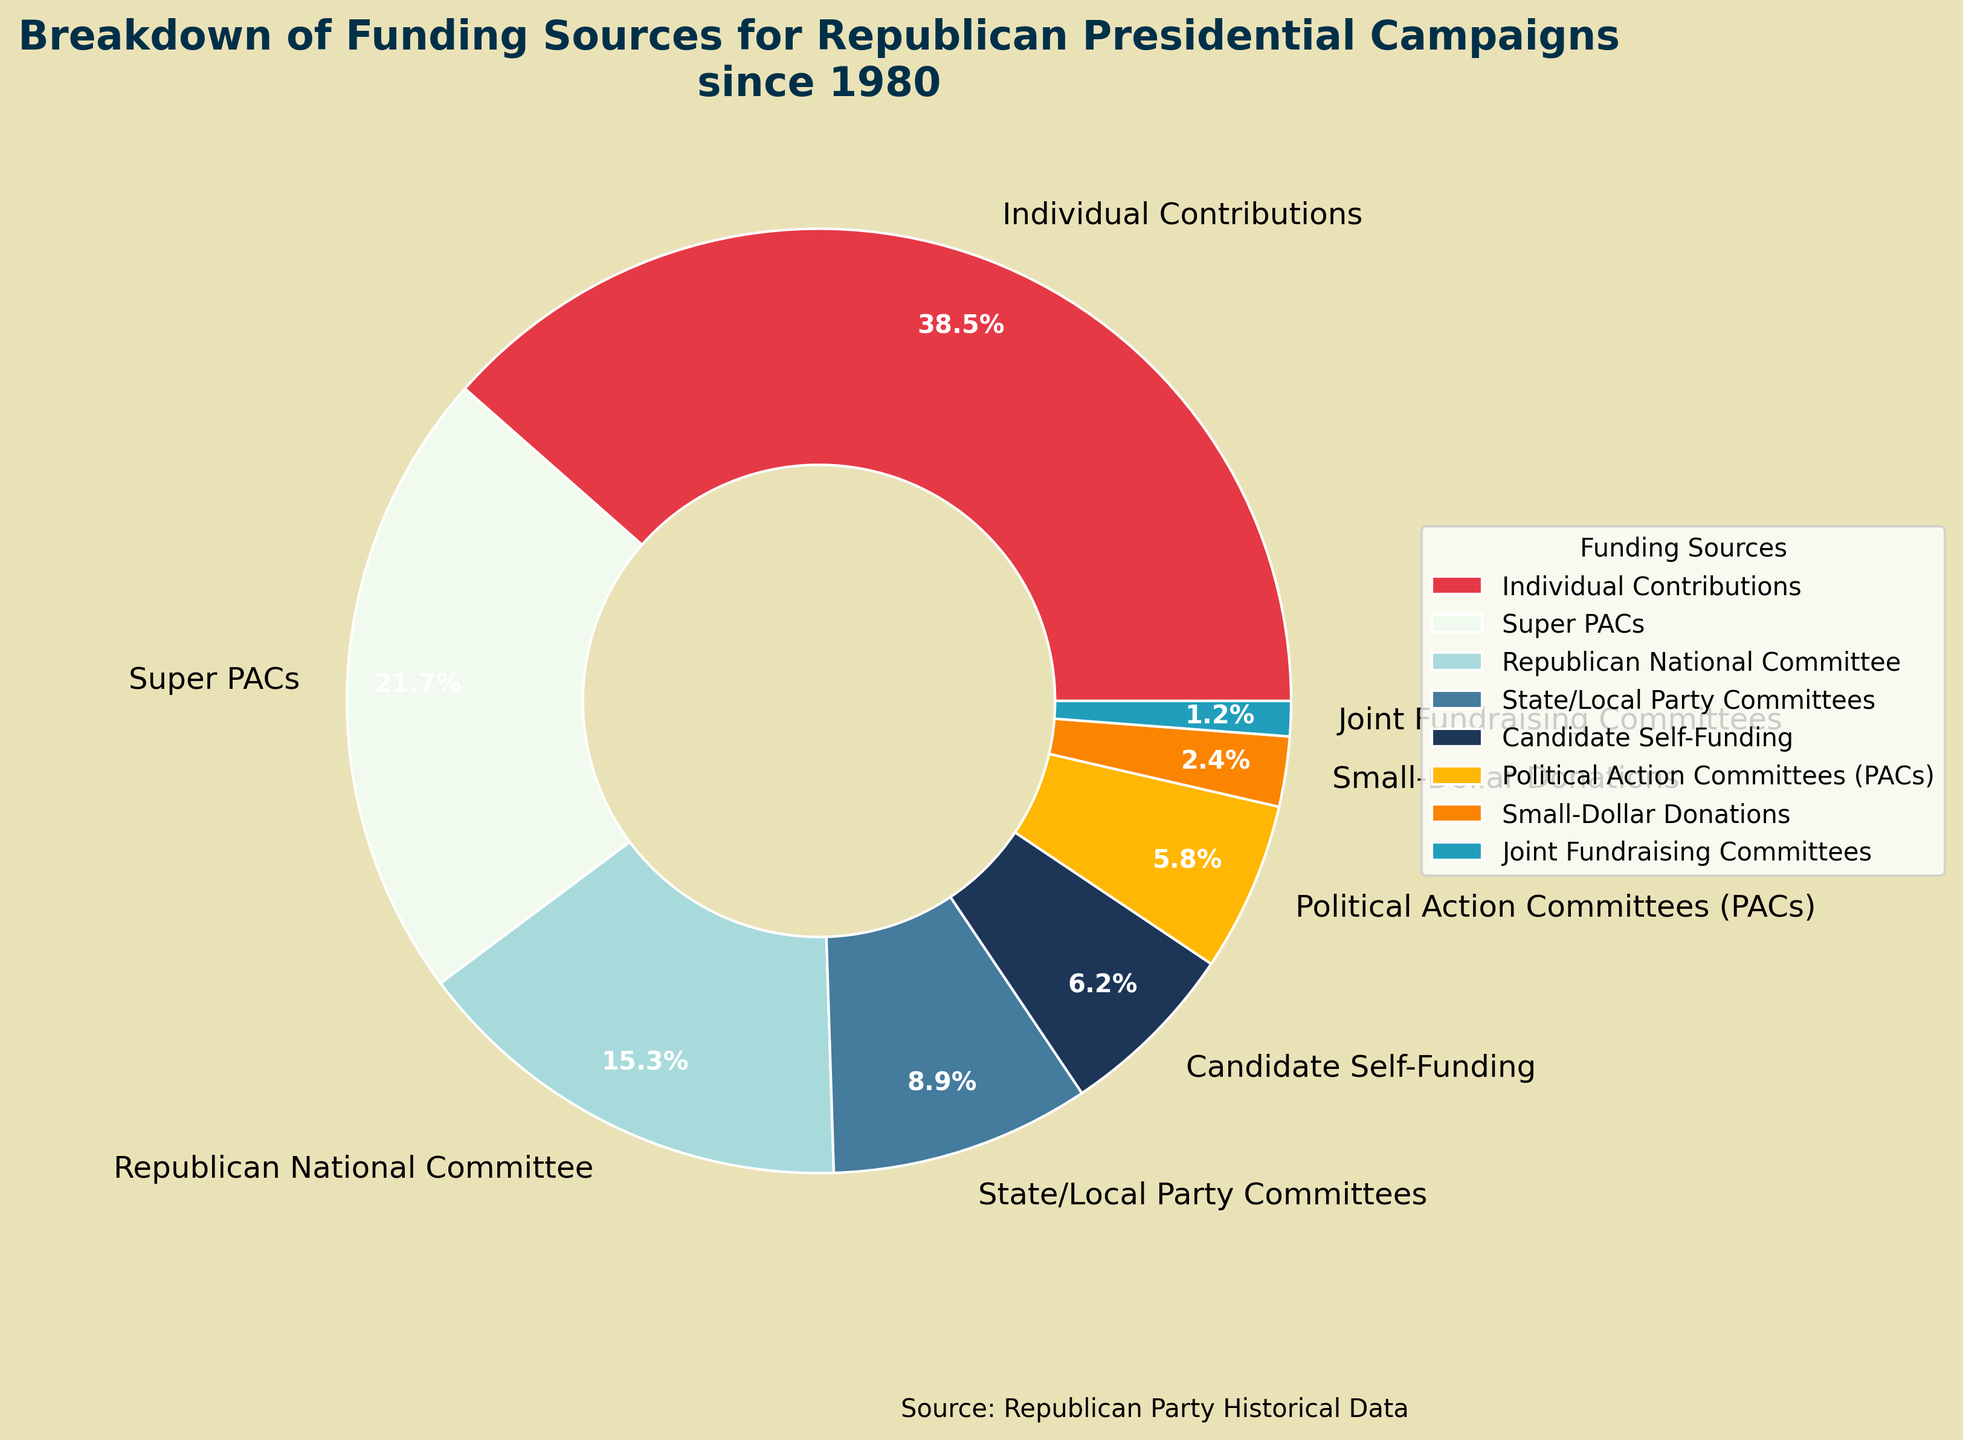What funding source contributes the most to Republican presidential campaigns? From the pie chart, the largest slice corresponds to "Individual Contributions" with 38.5%, indicating it is the biggest source of funding.
Answer: Individual Contributions How much more percentage do Super PACs contribute compared to PACs? First, identify the percentage for each category from the pie chart: Super PACs contribute 21.7%, and PACs contribute 5.8%. Calculate the difference: 21.7% - 5.8% = 15.9%.
Answer: 15.9% Which funding source contributes the least and by how much? The smallest slice in the pie chart corresponds to "Joint Fundraising Committees" with 1.2%. To confirm it's the least, scan all other percentages to compare.
Answer: Joint Fundraising Committees, 1.2% What two funding sources combined make up more than half of the total funding? Observing the pie chart, the two largest slices are "Individual Contributions" (38.5%) and "Super PACs" (21.7%). Adding these amounts: 38.5% + 21.7% = 60.2%. Thus, these two sources together exceed 50%.
Answer: Individual Contributions and Super PACs What is the contribution difference between the RNC and State/Local Party Committees? Locate the percentages: RNC (Republican National Committee) contributes 15.3%, and State/Local Party Committees contribute 8.9%. Calculate the difference: 15.3% - 8.9% = 6.4%.
Answer: 6.4% How many funding sources contribute less than 10% each? Identify the slices with percentages less than 10%: State/Local Party Committees (8.9%), Candidate Self-Funding (6.2%), PACs (5.8%), Small-Dollar Donations (2.4%), and Joint Fundraising Committees (1.2%). Count these categories: 5 sources.
Answer: 5 If Individual Contributions were reduced by 10 percentage points, which source would then contribute the most? Reducing Individual Contributions by 10 percentage points results in: 38.5% - 10% = 28.5%. Comparing the new value to other sources, the closest rival is Super PACs at 21.7%, but 28.5% remains higher. Thus Individual Contributions still lead.
Answer: Individual Contributions What is the combined contribution percentage of the RNC and PACs? Identify the percentages from the chart: RNC contributes 15.3% and PACs contribute 5.8%. Summing these amounts: 15.3% + 5.8% = 21.1%.
Answer: 21.1% What is the visual color of the wedge representing Small-Dollar Donations? Observing the pie chart, Small-Dollar Donations are represented with a distinctive color, which in this case, is orange.
Answer: Orange 